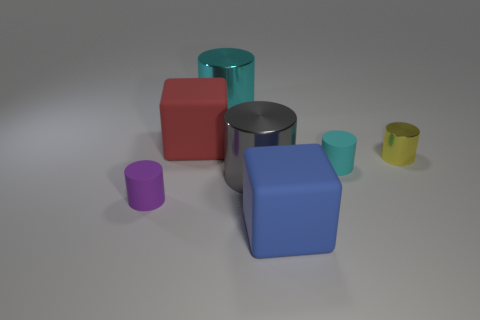Subtract all gray cylinders. How many cylinders are left? 4 Subtract 2 cylinders. How many cylinders are left? 3 Subtract all large cyan metallic cylinders. How many cylinders are left? 4 Subtract all blue cylinders. Subtract all green spheres. How many cylinders are left? 5 Add 2 large green metal cylinders. How many objects exist? 9 Subtract all blocks. How many objects are left? 5 Add 5 big blue blocks. How many big blue blocks are left? 6 Add 5 red rubber cylinders. How many red rubber cylinders exist? 5 Subtract 0 green blocks. How many objects are left? 7 Subtract all big red balls. Subtract all big blocks. How many objects are left? 5 